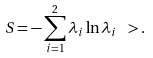<formula> <loc_0><loc_0><loc_500><loc_500>S = - \sum _ { i = 1 } ^ { 2 } \lambda _ { i } \ln \lambda _ { i } \ > .</formula> 